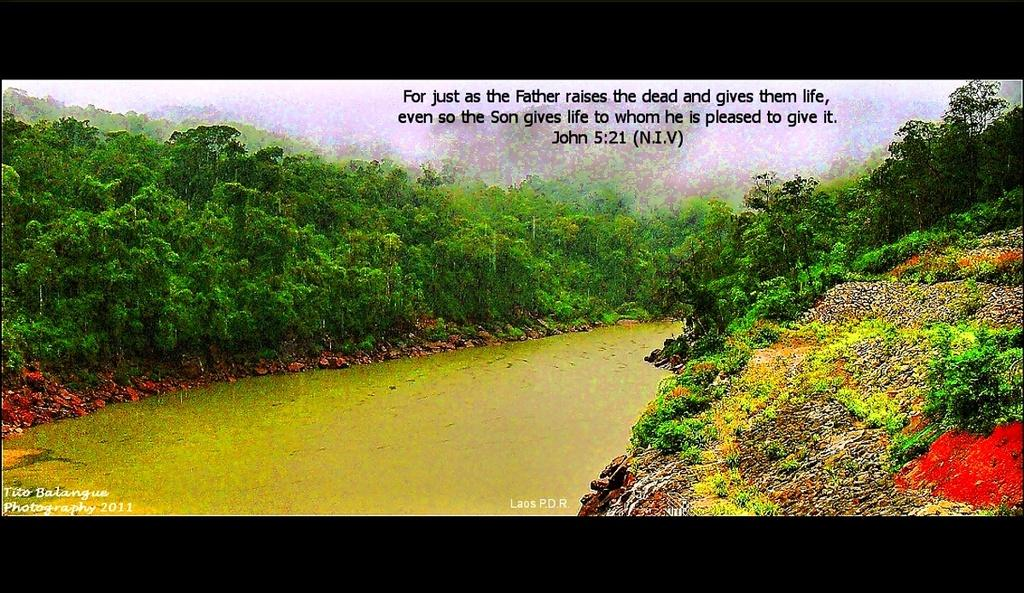What type of vegetation can be seen on both sides of the image? There are trees on both sides of the image. What natural element is visible in the image? Water is visible in the image. What type of small objects are present in the image? Small stones are present in the image. What type of plant is growing out of the elbow in the image? There is no elbow or plant growing out of it in the image; it only features trees, water, and small stones. 